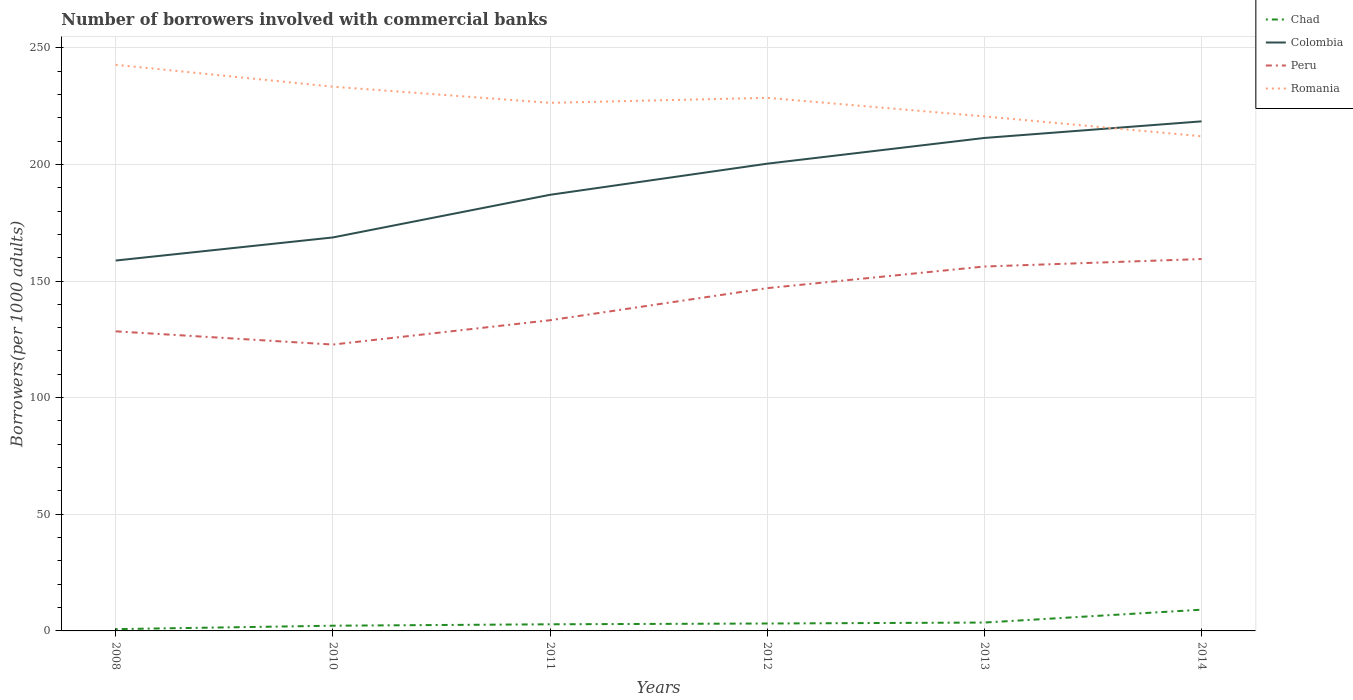How many different coloured lines are there?
Give a very brief answer. 4. Across all years, what is the maximum number of borrowers involved with commercial banks in Chad?
Provide a succinct answer. 0.77. What is the total number of borrowers involved with commercial banks in Colombia in the graph?
Make the answer very short. -18.28. What is the difference between the highest and the second highest number of borrowers involved with commercial banks in Romania?
Your answer should be compact. 30.64. What is the difference between the highest and the lowest number of borrowers involved with commercial banks in Romania?
Provide a short and direct response. 3. Is the number of borrowers involved with commercial banks in Peru strictly greater than the number of borrowers involved with commercial banks in Chad over the years?
Make the answer very short. No. How many years are there in the graph?
Your response must be concise. 6. Are the values on the major ticks of Y-axis written in scientific E-notation?
Keep it short and to the point. No. Does the graph contain grids?
Your answer should be compact. Yes. How many legend labels are there?
Your answer should be very brief. 4. What is the title of the graph?
Provide a succinct answer. Number of borrowers involved with commercial banks. Does "El Salvador" appear as one of the legend labels in the graph?
Your answer should be compact. No. What is the label or title of the X-axis?
Provide a succinct answer. Years. What is the label or title of the Y-axis?
Your answer should be compact. Borrowers(per 1000 adults). What is the Borrowers(per 1000 adults) in Chad in 2008?
Keep it short and to the point. 0.77. What is the Borrowers(per 1000 adults) of Colombia in 2008?
Ensure brevity in your answer.  158.77. What is the Borrowers(per 1000 adults) in Peru in 2008?
Offer a very short reply. 128.42. What is the Borrowers(per 1000 adults) of Romania in 2008?
Provide a short and direct response. 242.68. What is the Borrowers(per 1000 adults) in Chad in 2010?
Ensure brevity in your answer.  2.24. What is the Borrowers(per 1000 adults) of Colombia in 2010?
Offer a very short reply. 168.67. What is the Borrowers(per 1000 adults) of Peru in 2010?
Your response must be concise. 122.75. What is the Borrowers(per 1000 adults) of Romania in 2010?
Your answer should be very brief. 233.3. What is the Borrowers(per 1000 adults) of Chad in 2011?
Provide a succinct answer. 2.84. What is the Borrowers(per 1000 adults) in Colombia in 2011?
Offer a very short reply. 186.95. What is the Borrowers(per 1000 adults) in Peru in 2011?
Your response must be concise. 133.19. What is the Borrowers(per 1000 adults) in Romania in 2011?
Ensure brevity in your answer.  226.38. What is the Borrowers(per 1000 adults) in Chad in 2012?
Offer a very short reply. 3.18. What is the Borrowers(per 1000 adults) in Colombia in 2012?
Provide a short and direct response. 200.29. What is the Borrowers(per 1000 adults) of Peru in 2012?
Keep it short and to the point. 146.94. What is the Borrowers(per 1000 adults) in Romania in 2012?
Your answer should be compact. 228.51. What is the Borrowers(per 1000 adults) of Chad in 2013?
Offer a terse response. 3.59. What is the Borrowers(per 1000 adults) in Colombia in 2013?
Give a very brief answer. 211.32. What is the Borrowers(per 1000 adults) in Peru in 2013?
Offer a terse response. 156.21. What is the Borrowers(per 1000 adults) of Romania in 2013?
Your answer should be compact. 220.56. What is the Borrowers(per 1000 adults) in Chad in 2014?
Offer a terse response. 9.1. What is the Borrowers(per 1000 adults) of Colombia in 2014?
Provide a short and direct response. 218.44. What is the Borrowers(per 1000 adults) of Peru in 2014?
Make the answer very short. 159.42. What is the Borrowers(per 1000 adults) in Romania in 2014?
Offer a very short reply. 212.04. Across all years, what is the maximum Borrowers(per 1000 adults) in Chad?
Provide a short and direct response. 9.1. Across all years, what is the maximum Borrowers(per 1000 adults) of Colombia?
Make the answer very short. 218.44. Across all years, what is the maximum Borrowers(per 1000 adults) of Peru?
Provide a short and direct response. 159.42. Across all years, what is the maximum Borrowers(per 1000 adults) in Romania?
Your answer should be very brief. 242.68. Across all years, what is the minimum Borrowers(per 1000 adults) in Chad?
Your answer should be compact. 0.77. Across all years, what is the minimum Borrowers(per 1000 adults) in Colombia?
Give a very brief answer. 158.77. Across all years, what is the minimum Borrowers(per 1000 adults) in Peru?
Keep it short and to the point. 122.75. Across all years, what is the minimum Borrowers(per 1000 adults) of Romania?
Make the answer very short. 212.04. What is the total Borrowers(per 1000 adults) in Chad in the graph?
Provide a short and direct response. 21.72. What is the total Borrowers(per 1000 adults) of Colombia in the graph?
Your response must be concise. 1144.45. What is the total Borrowers(per 1000 adults) in Peru in the graph?
Provide a short and direct response. 846.93. What is the total Borrowers(per 1000 adults) of Romania in the graph?
Your answer should be very brief. 1363.48. What is the difference between the Borrowers(per 1000 adults) of Chad in 2008 and that in 2010?
Offer a very short reply. -1.46. What is the difference between the Borrowers(per 1000 adults) of Colombia in 2008 and that in 2010?
Your response must be concise. -9.9. What is the difference between the Borrowers(per 1000 adults) in Peru in 2008 and that in 2010?
Your answer should be compact. 5.67. What is the difference between the Borrowers(per 1000 adults) of Romania in 2008 and that in 2010?
Make the answer very short. 9.38. What is the difference between the Borrowers(per 1000 adults) in Chad in 2008 and that in 2011?
Keep it short and to the point. -2.07. What is the difference between the Borrowers(per 1000 adults) of Colombia in 2008 and that in 2011?
Keep it short and to the point. -28.18. What is the difference between the Borrowers(per 1000 adults) in Peru in 2008 and that in 2011?
Your answer should be compact. -4.77. What is the difference between the Borrowers(per 1000 adults) in Romania in 2008 and that in 2011?
Provide a short and direct response. 16.31. What is the difference between the Borrowers(per 1000 adults) in Chad in 2008 and that in 2012?
Make the answer very short. -2.41. What is the difference between the Borrowers(per 1000 adults) in Colombia in 2008 and that in 2012?
Make the answer very short. -41.52. What is the difference between the Borrowers(per 1000 adults) in Peru in 2008 and that in 2012?
Ensure brevity in your answer.  -18.52. What is the difference between the Borrowers(per 1000 adults) of Romania in 2008 and that in 2012?
Make the answer very short. 14.17. What is the difference between the Borrowers(per 1000 adults) in Chad in 2008 and that in 2013?
Keep it short and to the point. -2.82. What is the difference between the Borrowers(per 1000 adults) of Colombia in 2008 and that in 2013?
Ensure brevity in your answer.  -52.55. What is the difference between the Borrowers(per 1000 adults) of Peru in 2008 and that in 2013?
Offer a terse response. -27.79. What is the difference between the Borrowers(per 1000 adults) in Romania in 2008 and that in 2013?
Your answer should be very brief. 22.12. What is the difference between the Borrowers(per 1000 adults) of Chad in 2008 and that in 2014?
Make the answer very short. -8.32. What is the difference between the Borrowers(per 1000 adults) in Colombia in 2008 and that in 2014?
Ensure brevity in your answer.  -59.67. What is the difference between the Borrowers(per 1000 adults) of Peru in 2008 and that in 2014?
Give a very brief answer. -31. What is the difference between the Borrowers(per 1000 adults) of Romania in 2008 and that in 2014?
Make the answer very short. 30.64. What is the difference between the Borrowers(per 1000 adults) of Chad in 2010 and that in 2011?
Offer a very short reply. -0.61. What is the difference between the Borrowers(per 1000 adults) in Colombia in 2010 and that in 2011?
Make the answer very short. -18.28. What is the difference between the Borrowers(per 1000 adults) in Peru in 2010 and that in 2011?
Ensure brevity in your answer.  -10.43. What is the difference between the Borrowers(per 1000 adults) in Romania in 2010 and that in 2011?
Your response must be concise. 6.92. What is the difference between the Borrowers(per 1000 adults) of Chad in 2010 and that in 2012?
Offer a terse response. -0.94. What is the difference between the Borrowers(per 1000 adults) in Colombia in 2010 and that in 2012?
Your answer should be very brief. -31.62. What is the difference between the Borrowers(per 1000 adults) of Peru in 2010 and that in 2012?
Offer a terse response. -24.19. What is the difference between the Borrowers(per 1000 adults) in Romania in 2010 and that in 2012?
Keep it short and to the point. 4.79. What is the difference between the Borrowers(per 1000 adults) of Chad in 2010 and that in 2013?
Provide a succinct answer. -1.35. What is the difference between the Borrowers(per 1000 adults) of Colombia in 2010 and that in 2013?
Your answer should be very brief. -42.65. What is the difference between the Borrowers(per 1000 adults) of Peru in 2010 and that in 2013?
Provide a short and direct response. -33.46. What is the difference between the Borrowers(per 1000 adults) in Romania in 2010 and that in 2013?
Provide a short and direct response. 12.74. What is the difference between the Borrowers(per 1000 adults) in Chad in 2010 and that in 2014?
Offer a terse response. -6.86. What is the difference between the Borrowers(per 1000 adults) in Colombia in 2010 and that in 2014?
Your response must be concise. -49.76. What is the difference between the Borrowers(per 1000 adults) in Peru in 2010 and that in 2014?
Ensure brevity in your answer.  -36.66. What is the difference between the Borrowers(per 1000 adults) in Romania in 2010 and that in 2014?
Provide a short and direct response. 21.26. What is the difference between the Borrowers(per 1000 adults) of Chad in 2011 and that in 2012?
Ensure brevity in your answer.  -0.34. What is the difference between the Borrowers(per 1000 adults) in Colombia in 2011 and that in 2012?
Your response must be concise. -13.34. What is the difference between the Borrowers(per 1000 adults) in Peru in 2011 and that in 2012?
Provide a short and direct response. -13.75. What is the difference between the Borrowers(per 1000 adults) in Romania in 2011 and that in 2012?
Offer a terse response. -2.13. What is the difference between the Borrowers(per 1000 adults) of Chad in 2011 and that in 2013?
Make the answer very short. -0.75. What is the difference between the Borrowers(per 1000 adults) in Colombia in 2011 and that in 2013?
Offer a terse response. -24.37. What is the difference between the Borrowers(per 1000 adults) of Peru in 2011 and that in 2013?
Give a very brief answer. -23.02. What is the difference between the Borrowers(per 1000 adults) of Romania in 2011 and that in 2013?
Your answer should be compact. 5.82. What is the difference between the Borrowers(per 1000 adults) in Chad in 2011 and that in 2014?
Your response must be concise. -6.25. What is the difference between the Borrowers(per 1000 adults) of Colombia in 2011 and that in 2014?
Make the answer very short. -31.48. What is the difference between the Borrowers(per 1000 adults) in Peru in 2011 and that in 2014?
Your response must be concise. -26.23. What is the difference between the Borrowers(per 1000 adults) in Romania in 2011 and that in 2014?
Your answer should be compact. 14.34. What is the difference between the Borrowers(per 1000 adults) of Chad in 2012 and that in 2013?
Make the answer very short. -0.41. What is the difference between the Borrowers(per 1000 adults) of Colombia in 2012 and that in 2013?
Keep it short and to the point. -11.03. What is the difference between the Borrowers(per 1000 adults) in Peru in 2012 and that in 2013?
Offer a terse response. -9.27. What is the difference between the Borrowers(per 1000 adults) in Romania in 2012 and that in 2013?
Offer a very short reply. 7.95. What is the difference between the Borrowers(per 1000 adults) in Chad in 2012 and that in 2014?
Your response must be concise. -5.92. What is the difference between the Borrowers(per 1000 adults) in Colombia in 2012 and that in 2014?
Offer a terse response. -18.14. What is the difference between the Borrowers(per 1000 adults) of Peru in 2012 and that in 2014?
Ensure brevity in your answer.  -12.48. What is the difference between the Borrowers(per 1000 adults) in Romania in 2012 and that in 2014?
Ensure brevity in your answer.  16.47. What is the difference between the Borrowers(per 1000 adults) of Chad in 2013 and that in 2014?
Ensure brevity in your answer.  -5.51. What is the difference between the Borrowers(per 1000 adults) in Colombia in 2013 and that in 2014?
Your response must be concise. -7.11. What is the difference between the Borrowers(per 1000 adults) in Peru in 2013 and that in 2014?
Your answer should be very brief. -3.21. What is the difference between the Borrowers(per 1000 adults) in Romania in 2013 and that in 2014?
Provide a short and direct response. 8.52. What is the difference between the Borrowers(per 1000 adults) of Chad in 2008 and the Borrowers(per 1000 adults) of Colombia in 2010?
Make the answer very short. -167.9. What is the difference between the Borrowers(per 1000 adults) in Chad in 2008 and the Borrowers(per 1000 adults) in Peru in 2010?
Your response must be concise. -121.98. What is the difference between the Borrowers(per 1000 adults) in Chad in 2008 and the Borrowers(per 1000 adults) in Romania in 2010?
Your answer should be very brief. -232.53. What is the difference between the Borrowers(per 1000 adults) in Colombia in 2008 and the Borrowers(per 1000 adults) in Peru in 2010?
Your response must be concise. 36.02. What is the difference between the Borrowers(per 1000 adults) of Colombia in 2008 and the Borrowers(per 1000 adults) of Romania in 2010?
Offer a terse response. -74.53. What is the difference between the Borrowers(per 1000 adults) in Peru in 2008 and the Borrowers(per 1000 adults) in Romania in 2010?
Keep it short and to the point. -104.88. What is the difference between the Borrowers(per 1000 adults) in Chad in 2008 and the Borrowers(per 1000 adults) in Colombia in 2011?
Keep it short and to the point. -186.18. What is the difference between the Borrowers(per 1000 adults) of Chad in 2008 and the Borrowers(per 1000 adults) of Peru in 2011?
Offer a very short reply. -132.41. What is the difference between the Borrowers(per 1000 adults) of Chad in 2008 and the Borrowers(per 1000 adults) of Romania in 2011?
Your answer should be compact. -225.61. What is the difference between the Borrowers(per 1000 adults) of Colombia in 2008 and the Borrowers(per 1000 adults) of Peru in 2011?
Provide a short and direct response. 25.58. What is the difference between the Borrowers(per 1000 adults) in Colombia in 2008 and the Borrowers(per 1000 adults) in Romania in 2011?
Your answer should be compact. -67.61. What is the difference between the Borrowers(per 1000 adults) of Peru in 2008 and the Borrowers(per 1000 adults) of Romania in 2011?
Your answer should be very brief. -97.96. What is the difference between the Borrowers(per 1000 adults) in Chad in 2008 and the Borrowers(per 1000 adults) in Colombia in 2012?
Make the answer very short. -199.52. What is the difference between the Borrowers(per 1000 adults) in Chad in 2008 and the Borrowers(per 1000 adults) in Peru in 2012?
Your answer should be very brief. -146.17. What is the difference between the Borrowers(per 1000 adults) of Chad in 2008 and the Borrowers(per 1000 adults) of Romania in 2012?
Your answer should be very brief. -227.74. What is the difference between the Borrowers(per 1000 adults) of Colombia in 2008 and the Borrowers(per 1000 adults) of Peru in 2012?
Provide a short and direct response. 11.83. What is the difference between the Borrowers(per 1000 adults) in Colombia in 2008 and the Borrowers(per 1000 adults) in Romania in 2012?
Give a very brief answer. -69.74. What is the difference between the Borrowers(per 1000 adults) in Peru in 2008 and the Borrowers(per 1000 adults) in Romania in 2012?
Your answer should be compact. -100.09. What is the difference between the Borrowers(per 1000 adults) of Chad in 2008 and the Borrowers(per 1000 adults) of Colombia in 2013?
Keep it short and to the point. -210.55. What is the difference between the Borrowers(per 1000 adults) of Chad in 2008 and the Borrowers(per 1000 adults) of Peru in 2013?
Ensure brevity in your answer.  -155.44. What is the difference between the Borrowers(per 1000 adults) in Chad in 2008 and the Borrowers(per 1000 adults) in Romania in 2013?
Your answer should be very brief. -219.79. What is the difference between the Borrowers(per 1000 adults) of Colombia in 2008 and the Borrowers(per 1000 adults) of Peru in 2013?
Provide a short and direct response. 2.56. What is the difference between the Borrowers(per 1000 adults) in Colombia in 2008 and the Borrowers(per 1000 adults) in Romania in 2013?
Provide a short and direct response. -61.79. What is the difference between the Borrowers(per 1000 adults) of Peru in 2008 and the Borrowers(per 1000 adults) of Romania in 2013?
Keep it short and to the point. -92.14. What is the difference between the Borrowers(per 1000 adults) of Chad in 2008 and the Borrowers(per 1000 adults) of Colombia in 2014?
Provide a short and direct response. -217.66. What is the difference between the Borrowers(per 1000 adults) of Chad in 2008 and the Borrowers(per 1000 adults) of Peru in 2014?
Provide a short and direct response. -158.64. What is the difference between the Borrowers(per 1000 adults) of Chad in 2008 and the Borrowers(per 1000 adults) of Romania in 2014?
Your response must be concise. -211.27. What is the difference between the Borrowers(per 1000 adults) in Colombia in 2008 and the Borrowers(per 1000 adults) in Peru in 2014?
Your answer should be very brief. -0.65. What is the difference between the Borrowers(per 1000 adults) of Colombia in 2008 and the Borrowers(per 1000 adults) of Romania in 2014?
Offer a terse response. -53.27. What is the difference between the Borrowers(per 1000 adults) in Peru in 2008 and the Borrowers(per 1000 adults) in Romania in 2014?
Give a very brief answer. -83.62. What is the difference between the Borrowers(per 1000 adults) of Chad in 2010 and the Borrowers(per 1000 adults) of Colombia in 2011?
Your answer should be compact. -184.72. What is the difference between the Borrowers(per 1000 adults) of Chad in 2010 and the Borrowers(per 1000 adults) of Peru in 2011?
Keep it short and to the point. -130.95. What is the difference between the Borrowers(per 1000 adults) of Chad in 2010 and the Borrowers(per 1000 adults) of Romania in 2011?
Offer a terse response. -224.14. What is the difference between the Borrowers(per 1000 adults) of Colombia in 2010 and the Borrowers(per 1000 adults) of Peru in 2011?
Provide a succinct answer. 35.49. What is the difference between the Borrowers(per 1000 adults) in Colombia in 2010 and the Borrowers(per 1000 adults) in Romania in 2011?
Provide a succinct answer. -57.71. What is the difference between the Borrowers(per 1000 adults) of Peru in 2010 and the Borrowers(per 1000 adults) of Romania in 2011?
Provide a succinct answer. -103.63. What is the difference between the Borrowers(per 1000 adults) of Chad in 2010 and the Borrowers(per 1000 adults) of Colombia in 2012?
Give a very brief answer. -198.06. What is the difference between the Borrowers(per 1000 adults) of Chad in 2010 and the Borrowers(per 1000 adults) of Peru in 2012?
Offer a terse response. -144.71. What is the difference between the Borrowers(per 1000 adults) in Chad in 2010 and the Borrowers(per 1000 adults) in Romania in 2012?
Offer a terse response. -226.28. What is the difference between the Borrowers(per 1000 adults) in Colombia in 2010 and the Borrowers(per 1000 adults) in Peru in 2012?
Your answer should be compact. 21.73. What is the difference between the Borrowers(per 1000 adults) in Colombia in 2010 and the Borrowers(per 1000 adults) in Romania in 2012?
Your answer should be compact. -59.84. What is the difference between the Borrowers(per 1000 adults) in Peru in 2010 and the Borrowers(per 1000 adults) in Romania in 2012?
Offer a very short reply. -105.76. What is the difference between the Borrowers(per 1000 adults) of Chad in 2010 and the Borrowers(per 1000 adults) of Colombia in 2013?
Offer a terse response. -209.09. What is the difference between the Borrowers(per 1000 adults) in Chad in 2010 and the Borrowers(per 1000 adults) in Peru in 2013?
Provide a succinct answer. -153.97. What is the difference between the Borrowers(per 1000 adults) in Chad in 2010 and the Borrowers(per 1000 adults) in Romania in 2013?
Make the answer very short. -218.33. What is the difference between the Borrowers(per 1000 adults) in Colombia in 2010 and the Borrowers(per 1000 adults) in Peru in 2013?
Provide a short and direct response. 12.46. What is the difference between the Borrowers(per 1000 adults) of Colombia in 2010 and the Borrowers(per 1000 adults) of Romania in 2013?
Your answer should be compact. -51.89. What is the difference between the Borrowers(per 1000 adults) in Peru in 2010 and the Borrowers(per 1000 adults) in Romania in 2013?
Give a very brief answer. -97.81. What is the difference between the Borrowers(per 1000 adults) in Chad in 2010 and the Borrowers(per 1000 adults) in Colombia in 2014?
Offer a terse response. -216.2. What is the difference between the Borrowers(per 1000 adults) in Chad in 2010 and the Borrowers(per 1000 adults) in Peru in 2014?
Provide a succinct answer. -157.18. What is the difference between the Borrowers(per 1000 adults) in Chad in 2010 and the Borrowers(per 1000 adults) in Romania in 2014?
Keep it short and to the point. -209.81. What is the difference between the Borrowers(per 1000 adults) in Colombia in 2010 and the Borrowers(per 1000 adults) in Peru in 2014?
Provide a succinct answer. 9.26. What is the difference between the Borrowers(per 1000 adults) of Colombia in 2010 and the Borrowers(per 1000 adults) of Romania in 2014?
Your answer should be compact. -43.37. What is the difference between the Borrowers(per 1000 adults) of Peru in 2010 and the Borrowers(per 1000 adults) of Romania in 2014?
Provide a short and direct response. -89.29. What is the difference between the Borrowers(per 1000 adults) in Chad in 2011 and the Borrowers(per 1000 adults) in Colombia in 2012?
Provide a succinct answer. -197.45. What is the difference between the Borrowers(per 1000 adults) of Chad in 2011 and the Borrowers(per 1000 adults) of Peru in 2012?
Keep it short and to the point. -144.1. What is the difference between the Borrowers(per 1000 adults) of Chad in 2011 and the Borrowers(per 1000 adults) of Romania in 2012?
Offer a terse response. -225.67. What is the difference between the Borrowers(per 1000 adults) in Colombia in 2011 and the Borrowers(per 1000 adults) in Peru in 2012?
Provide a succinct answer. 40.01. What is the difference between the Borrowers(per 1000 adults) in Colombia in 2011 and the Borrowers(per 1000 adults) in Romania in 2012?
Your answer should be very brief. -41.56. What is the difference between the Borrowers(per 1000 adults) in Peru in 2011 and the Borrowers(per 1000 adults) in Romania in 2012?
Your response must be concise. -95.32. What is the difference between the Borrowers(per 1000 adults) of Chad in 2011 and the Borrowers(per 1000 adults) of Colombia in 2013?
Your answer should be very brief. -208.48. What is the difference between the Borrowers(per 1000 adults) of Chad in 2011 and the Borrowers(per 1000 adults) of Peru in 2013?
Offer a very short reply. -153.37. What is the difference between the Borrowers(per 1000 adults) in Chad in 2011 and the Borrowers(per 1000 adults) in Romania in 2013?
Make the answer very short. -217.72. What is the difference between the Borrowers(per 1000 adults) in Colombia in 2011 and the Borrowers(per 1000 adults) in Peru in 2013?
Your answer should be very brief. 30.75. What is the difference between the Borrowers(per 1000 adults) of Colombia in 2011 and the Borrowers(per 1000 adults) of Romania in 2013?
Make the answer very short. -33.61. What is the difference between the Borrowers(per 1000 adults) of Peru in 2011 and the Borrowers(per 1000 adults) of Romania in 2013?
Your answer should be compact. -87.38. What is the difference between the Borrowers(per 1000 adults) of Chad in 2011 and the Borrowers(per 1000 adults) of Colombia in 2014?
Keep it short and to the point. -215.59. What is the difference between the Borrowers(per 1000 adults) of Chad in 2011 and the Borrowers(per 1000 adults) of Peru in 2014?
Give a very brief answer. -156.57. What is the difference between the Borrowers(per 1000 adults) in Chad in 2011 and the Borrowers(per 1000 adults) in Romania in 2014?
Offer a very short reply. -209.2. What is the difference between the Borrowers(per 1000 adults) of Colombia in 2011 and the Borrowers(per 1000 adults) of Peru in 2014?
Make the answer very short. 27.54. What is the difference between the Borrowers(per 1000 adults) in Colombia in 2011 and the Borrowers(per 1000 adults) in Romania in 2014?
Give a very brief answer. -25.09. What is the difference between the Borrowers(per 1000 adults) in Peru in 2011 and the Borrowers(per 1000 adults) in Romania in 2014?
Ensure brevity in your answer.  -78.86. What is the difference between the Borrowers(per 1000 adults) of Chad in 2012 and the Borrowers(per 1000 adults) of Colombia in 2013?
Your answer should be compact. -208.14. What is the difference between the Borrowers(per 1000 adults) of Chad in 2012 and the Borrowers(per 1000 adults) of Peru in 2013?
Give a very brief answer. -153.03. What is the difference between the Borrowers(per 1000 adults) of Chad in 2012 and the Borrowers(per 1000 adults) of Romania in 2013?
Make the answer very short. -217.38. What is the difference between the Borrowers(per 1000 adults) in Colombia in 2012 and the Borrowers(per 1000 adults) in Peru in 2013?
Ensure brevity in your answer.  44.08. What is the difference between the Borrowers(per 1000 adults) of Colombia in 2012 and the Borrowers(per 1000 adults) of Romania in 2013?
Keep it short and to the point. -20.27. What is the difference between the Borrowers(per 1000 adults) of Peru in 2012 and the Borrowers(per 1000 adults) of Romania in 2013?
Your answer should be very brief. -73.62. What is the difference between the Borrowers(per 1000 adults) in Chad in 2012 and the Borrowers(per 1000 adults) in Colombia in 2014?
Provide a short and direct response. -215.26. What is the difference between the Borrowers(per 1000 adults) of Chad in 2012 and the Borrowers(per 1000 adults) of Peru in 2014?
Make the answer very short. -156.24. What is the difference between the Borrowers(per 1000 adults) of Chad in 2012 and the Borrowers(per 1000 adults) of Romania in 2014?
Provide a succinct answer. -208.86. What is the difference between the Borrowers(per 1000 adults) in Colombia in 2012 and the Borrowers(per 1000 adults) in Peru in 2014?
Give a very brief answer. 40.88. What is the difference between the Borrowers(per 1000 adults) of Colombia in 2012 and the Borrowers(per 1000 adults) of Romania in 2014?
Provide a succinct answer. -11.75. What is the difference between the Borrowers(per 1000 adults) in Peru in 2012 and the Borrowers(per 1000 adults) in Romania in 2014?
Provide a short and direct response. -65.1. What is the difference between the Borrowers(per 1000 adults) of Chad in 2013 and the Borrowers(per 1000 adults) of Colombia in 2014?
Offer a terse response. -214.85. What is the difference between the Borrowers(per 1000 adults) in Chad in 2013 and the Borrowers(per 1000 adults) in Peru in 2014?
Give a very brief answer. -155.83. What is the difference between the Borrowers(per 1000 adults) of Chad in 2013 and the Borrowers(per 1000 adults) of Romania in 2014?
Offer a terse response. -208.45. What is the difference between the Borrowers(per 1000 adults) of Colombia in 2013 and the Borrowers(per 1000 adults) of Peru in 2014?
Offer a terse response. 51.9. What is the difference between the Borrowers(per 1000 adults) in Colombia in 2013 and the Borrowers(per 1000 adults) in Romania in 2014?
Give a very brief answer. -0.72. What is the difference between the Borrowers(per 1000 adults) of Peru in 2013 and the Borrowers(per 1000 adults) of Romania in 2014?
Provide a short and direct response. -55.83. What is the average Borrowers(per 1000 adults) in Chad per year?
Give a very brief answer. 3.62. What is the average Borrowers(per 1000 adults) of Colombia per year?
Your answer should be very brief. 190.74. What is the average Borrowers(per 1000 adults) in Peru per year?
Provide a short and direct response. 141.15. What is the average Borrowers(per 1000 adults) in Romania per year?
Ensure brevity in your answer.  227.25. In the year 2008, what is the difference between the Borrowers(per 1000 adults) of Chad and Borrowers(per 1000 adults) of Colombia?
Make the answer very short. -158. In the year 2008, what is the difference between the Borrowers(per 1000 adults) of Chad and Borrowers(per 1000 adults) of Peru?
Give a very brief answer. -127.65. In the year 2008, what is the difference between the Borrowers(per 1000 adults) in Chad and Borrowers(per 1000 adults) in Romania?
Offer a terse response. -241.91. In the year 2008, what is the difference between the Borrowers(per 1000 adults) in Colombia and Borrowers(per 1000 adults) in Peru?
Offer a very short reply. 30.35. In the year 2008, what is the difference between the Borrowers(per 1000 adults) in Colombia and Borrowers(per 1000 adults) in Romania?
Your response must be concise. -83.91. In the year 2008, what is the difference between the Borrowers(per 1000 adults) in Peru and Borrowers(per 1000 adults) in Romania?
Offer a terse response. -114.26. In the year 2010, what is the difference between the Borrowers(per 1000 adults) of Chad and Borrowers(per 1000 adults) of Colombia?
Your answer should be very brief. -166.44. In the year 2010, what is the difference between the Borrowers(per 1000 adults) of Chad and Borrowers(per 1000 adults) of Peru?
Your answer should be very brief. -120.52. In the year 2010, what is the difference between the Borrowers(per 1000 adults) of Chad and Borrowers(per 1000 adults) of Romania?
Provide a short and direct response. -231.06. In the year 2010, what is the difference between the Borrowers(per 1000 adults) of Colombia and Borrowers(per 1000 adults) of Peru?
Give a very brief answer. 45.92. In the year 2010, what is the difference between the Borrowers(per 1000 adults) of Colombia and Borrowers(per 1000 adults) of Romania?
Offer a very short reply. -64.63. In the year 2010, what is the difference between the Borrowers(per 1000 adults) of Peru and Borrowers(per 1000 adults) of Romania?
Ensure brevity in your answer.  -110.55. In the year 2011, what is the difference between the Borrowers(per 1000 adults) of Chad and Borrowers(per 1000 adults) of Colombia?
Your answer should be compact. -184.11. In the year 2011, what is the difference between the Borrowers(per 1000 adults) of Chad and Borrowers(per 1000 adults) of Peru?
Offer a terse response. -130.34. In the year 2011, what is the difference between the Borrowers(per 1000 adults) of Chad and Borrowers(per 1000 adults) of Romania?
Provide a short and direct response. -223.54. In the year 2011, what is the difference between the Borrowers(per 1000 adults) in Colombia and Borrowers(per 1000 adults) in Peru?
Your response must be concise. 53.77. In the year 2011, what is the difference between the Borrowers(per 1000 adults) of Colombia and Borrowers(per 1000 adults) of Romania?
Keep it short and to the point. -39.42. In the year 2011, what is the difference between the Borrowers(per 1000 adults) of Peru and Borrowers(per 1000 adults) of Romania?
Provide a short and direct response. -93.19. In the year 2012, what is the difference between the Borrowers(per 1000 adults) of Chad and Borrowers(per 1000 adults) of Colombia?
Make the answer very short. -197.11. In the year 2012, what is the difference between the Borrowers(per 1000 adults) of Chad and Borrowers(per 1000 adults) of Peru?
Your answer should be compact. -143.76. In the year 2012, what is the difference between the Borrowers(per 1000 adults) of Chad and Borrowers(per 1000 adults) of Romania?
Make the answer very short. -225.33. In the year 2012, what is the difference between the Borrowers(per 1000 adults) of Colombia and Borrowers(per 1000 adults) of Peru?
Ensure brevity in your answer.  53.35. In the year 2012, what is the difference between the Borrowers(per 1000 adults) of Colombia and Borrowers(per 1000 adults) of Romania?
Provide a succinct answer. -28.22. In the year 2012, what is the difference between the Borrowers(per 1000 adults) in Peru and Borrowers(per 1000 adults) in Romania?
Provide a short and direct response. -81.57. In the year 2013, what is the difference between the Borrowers(per 1000 adults) of Chad and Borrowers(per 1000 adults) of Colombia?
Provide a short and direct response. -207.73. In the year 2013, what is the difference between the Borrowers(per 1000 adults) in Chad and Borrowers(per 1000 adults) in Peru?
Provide a succinct answer. -152.62. In the year 2013, what is the difference between the Borrowers(per 1000 adults) in Chad and Borrowers(per 1000 adults) in Romania?
Offer a very short reply. -216.97. In the year 2013, what is the difference between the Borrowers(per 1000 adults) of Colombia and Borrowers(per 1000 adults) of Peru?
Offer a very short reply. 55.11. In the year 2013, what is the difference between the Borrowers(per 1000 adults) in Colombia and Borrowers(per 1000 adults) in Romania?
Offer a very short reply. -9.24. In the year 2013, what is the difference between the Borrowers(per 1000 adults) in Peru and Borrowers(per 1000 adults) in Romania?
Give a very brief answer. -64.35. In the year 2014, what is the difference between the Borrowers(per 1000 adults) in Chad and Borrowers(per 1000 adults) in Colombia?
Give a very brief answer. -209.34. In the year 2014, what is the difference between the Borrowers(per 1000 adults) of Chad and Borrowers(per 1000 adults) of Peru?
Ensure brevity in your answer.  -150.32. In the year 2014, what is the difference between the Borrowers(per 1000 adults) of Chad and Borrowers(per 1000 adults) of Romania?
Give a very brief answer. -202.95. In the year 2014, what is the difference between the Borrowers(per 1000 adults) in Colombia and Borrowers(per 1000 adults) in Peru?
Keep it short and to the point. 59.02. In the year 2014, what is the difference between the Borrowers(per 1000 adults) of Colombia and Borrowers(per 1000 adults) of Romania?
Make the answer very short. 6.39. In the year 2014, what is the difference between the Borrowers(per 1000 adults) in Peru and Borrowers(per 1000 adults) in Romania?
Offer a terse response. -52.63. What is the ratio of the Borrowers(per 1000 adults) of Chad in 2008 to that in 2010?
Provide a short and direct response. 0.35. What is the ratio of the Borrowers(per 1000 adults) in Colombia in 2008 to that in 2010?
Ensure brevity in your answer.  0.94. What is the ratio of the Borrowers(per 1000 adults) of Peru in 2008 to that in 2010?
Keep it short and to the point. 1.05. What is the ratio of the Borrowers(per 1000 adults) of Romania in 2008 to that in 2010?
Your answer should be very brief. 1.04. What is the ratio of the Borrowers(per 1000 adults) in Chad in 2008 to that in 2011?
Provide a short and direct response. 0.27. What is the ratio of the Borrowers(per 1000 adults) in Colombia in 2008 to that in 2011?
Your answer should be very brief. 0.85. What is the ratio of the Borrowers(per 1000 adults) in Peru in 2008 to that in 2011?
Make the answer very short. 0.96. What is the ratio of the Borrowers(per 1000 adults) of Romania in 2008 to that in 2011?
Your answer should be very brief. 1.07. What is the ratio of the Borrowers(per 1000 adults) in Chad in 2008 to that in 2012?
Keep it short and to the point. 0.24. What is the ratio of the Borrowers(per 1000 adults) of Colombia in 2008 to that in 2012?
Your response must be concise. 0.79. What is the ratio of the Borrowers(per 1000 adults) in Peru in 2008 to that in 2012?
Your answer should be very brief. 0.87. What is the ratio of the Borrowers(per 1000 adults) in Romania in 2008 to that in 2012?
Your response must be concise. 1.06. What is the ratio of the Borrowers(per 1000 adults) of Chad in 2008 to that in 2013?
Provide a succinct answer. 0.22. What is the ratio of the Borrowers(per 1000 adults) in Colombia in 2008 to that in 2013?
Offer a terse response. 0.75. What is the ratio of the Borrowers(per 1000 adults) of Peru in 2008 to that in 2013?
Give a very brief answer. 0.82. What is the ratio of the Borrowers(per 1000 adults) of Romania in 2008 to that in 2013?
Your response must be concise. 1.1. What is the ratio of the Borrowers(per 1000 adults) of Chad in 2008 to that in 2014?
Give a very brief answer. 0.08. What is the ratio of the Borrowers(per 1000 adults) in Colombia in 2008 to that in 2014?
Your answer should be compact. 0.73. What is the ratio of the Borrowers(per 1000 adults) in Peru in 2008 to that in 2014?
Your answer should be compact. 0.81. What is the ratio of the Borrowers(per 1000 adults) in Romania in 2008 to that in 2014?
Your answer should be compact. 1.14. What is the ratio of the Borrowers(per 1000 adults) in Chad in 2010 to that in 2011?
Offer a terse response. 0.79. What is the ratio of the Borrowers(per 1000 adults) in Colombia in 2010 to that in 2011?
Your response must be concise. 0.9. What is the ratio of the Borrowers(per 1000 adults) of Peru in 2010 to that in 2011?
Offer a terse response. 0.92. What is the ratio of the Borrowers(per 1000 adults) in Romania in 2010 to that in 2011?
Your answer should be very brief. 1.03. What is the ratio of the Borrowers(per 1000 adults) in Chad in 2010 to that in 2012?
Keep it short and to the point. 0.7. What is the ratio of the Borrowers(per 1000 adults) of Colombia in 2010 to that in 2012?
Your answer should be very brief. 0.84. What is the ratio of the Borrowers(per 1000 adults) in Peru in 2010 to that in 2012?
Keep it short and to the point. 0.84. What is the ratio of the Borrowers(per 1000 adults) of Chad in 2010 to that in 2013?
Provide a succinct answer. 0.62. What is the ratio of the Borrowers(per 1000 adults) of Colombia in 2010 to that in 2013?
Provide a succinct answer. 0.8. What is the ratio of the Borrowers(per 1000 adults) of Peru in 2010 to that in 2013?
Offer a very short reply. 0.79. What is the ratio of the Borrowers(per 1000 adults) in Romania in 2010 to that in 2013?
Your response must be concise. 1.06. What is the ratio of the Borrowers(per 1000 adults) in Chad in 2010 to that in 2014?
Provide a succinct answer. 0.25. What is the ratio of the Borrowers(per 1000 adults) in Colombia in 2010 to that in 2014?
Offer a terse response. 0.77. What is the ratio of the Borrowers(per 1000 adults) of Peru in 2010 to that in 2014?
Ensure brevity in your answer.  0.77. What is the ratio of the Borrowers(per 1000 adults) in Romania in 2010 to that in 2014?
Your answer should be very brief. 1.1. What is the ratio of the Borrowers(per 1000 adults) of Chad in 2011 to that in 2012?
Offer a terse response. 0.89. What is the ratio of the Borrowers(per 1000 adults) of Colombia in 2011 to that in 2012?
Provide a succinct answer. 0.93. What is the ratio of the Borrowers(per 1000 adults) of Peru in 2011 to that in 2012?
Offer a very short reply. 0.91. What is the ratio of the Borrowers(per 1000 adults) of Romania in 2011 to that in 2012?
Make the answer very short. 0.99. What is the ratio of the Borrowers(per 1000 adults) in Chad in 2011 to that in 2013?
Your answer should be very brief. 0.79. What is the ratio of the Borrowers(per 1000 adults) of Colombia in 2011 to that in 2013?
Give a very brief answer. 0.88. What is the ratio of the Borrowers(per 1000 adults) of Peru in 2011 to that in 2013?
Make the answer very short. 0.85. What is the ratio of the Borrowers(per 1000 adults) of Romania in 2011 to that in 2013?
Your answer should be very brief. 1.03. What is the ratio of the Borrowers(per 1000 adults) of Chad in 2011 to that in 2014?
Provide a succinct answer. 0.31. What is the ratio of the Borrowers(per 1000 adults) of Colombia in 2011 to that in 2014?
Give a very brief answer. 0.86. What is the ratio of the Borrowers(per 1000 adults) in Peru in 2011 to that in 2014?
Provide a succinct answer. 0.84. What is the ratio of the Borrowers(per 1000 adults) in Romania in 2011 to that in 2014?
Provide a succinct answer. 1.07. What is the ratio of the Borrowers(per 1000 adults) in Chad in 2012 to that in 2013?
Keep it short and to the point. 0.89. What is the ratio of the Borrowers(per 1000 adults) in Colombia in 2012 to that in 2013?
Make the answer very short. 0.95. What is the ratio of the Borrowers(per 1000 adults) of Peru in 2012 to that in 2013?
Your answer should be compact. 0.94. What is the ratio of the Borrowers(per 1000 adults) of Romania in 2012 to that in 2013?
Provide a succinct answer. 1.04. What is the ratio of the Borrowers(per 1000 adults) in Chad in 2012 to that in 2014?
Your answer should be compact. 0.35. What is the ratio of the Borrowers(per 1000 adults) in Colombia in 2012 to that in 2014?
Provide a succinct answer. 0.92. What is the ratio of the Borrowers(per 1000 adults) in Peru in 2012 to that in 2014?
Your answer should be very brief. 0.92. What is the ratio of the Borrowers(per 1000 adults) of Romania in 2012 to that in 2014?
Offer a very short reply. 1.08. What is the ratio of the Borrowers(per 1000 adults) in Chad in 2013 to that in 2014?
Ensure brevity in your answer.  0.39. What is the ratio of the Borrowers(per 1000 adults) of Colombia in 2013 to that in 2014?
Your answer should be very brief. 0.97. What is the ratio of the Borrowers(per 1000 adults) of Peru in 2013 to that in 2014?
Your response must be concise. 0.98. What is the ratio of the Borrowers(per 1000 adults) of Romania in 2013 to that in 2014?
Your response must be concise. 1.04. What is the difference between the highest and the second highest Borrowers(per 1000 adults) in Chad?
Give a very brief answer. 5.51. What is the difference between the highest and the second highest Borrowers(per 1000 adults) in Colombia?
Offer a terse response. 7.11. What is the difference between the highest and the second highest Borrowers(per 1000 adults) of Peru?
Make the answer very short. 3.21. What is the difference between the highest and the second highest Borrowers(per 1000 adults) of Romania?
Offer a very short reply. 9.38. What is the difference between the highest and the lowest Borrowers(per 1000 adults) in Chad?
Your response must be concise. 8.32. What is the difference between the highest and the lowest Borrowers(per 1000 adults) in Colombia?
Offer a terse response. 59.67. What is the difference between the highest and the lowest Borrowers(per 1000 adults) in Peru?
Offer a terse response. 36.66. What is the difference between the highest and the lowest Borrowers(per 1000 adults) in Romania?
Your answer should be compact. 30.64. 